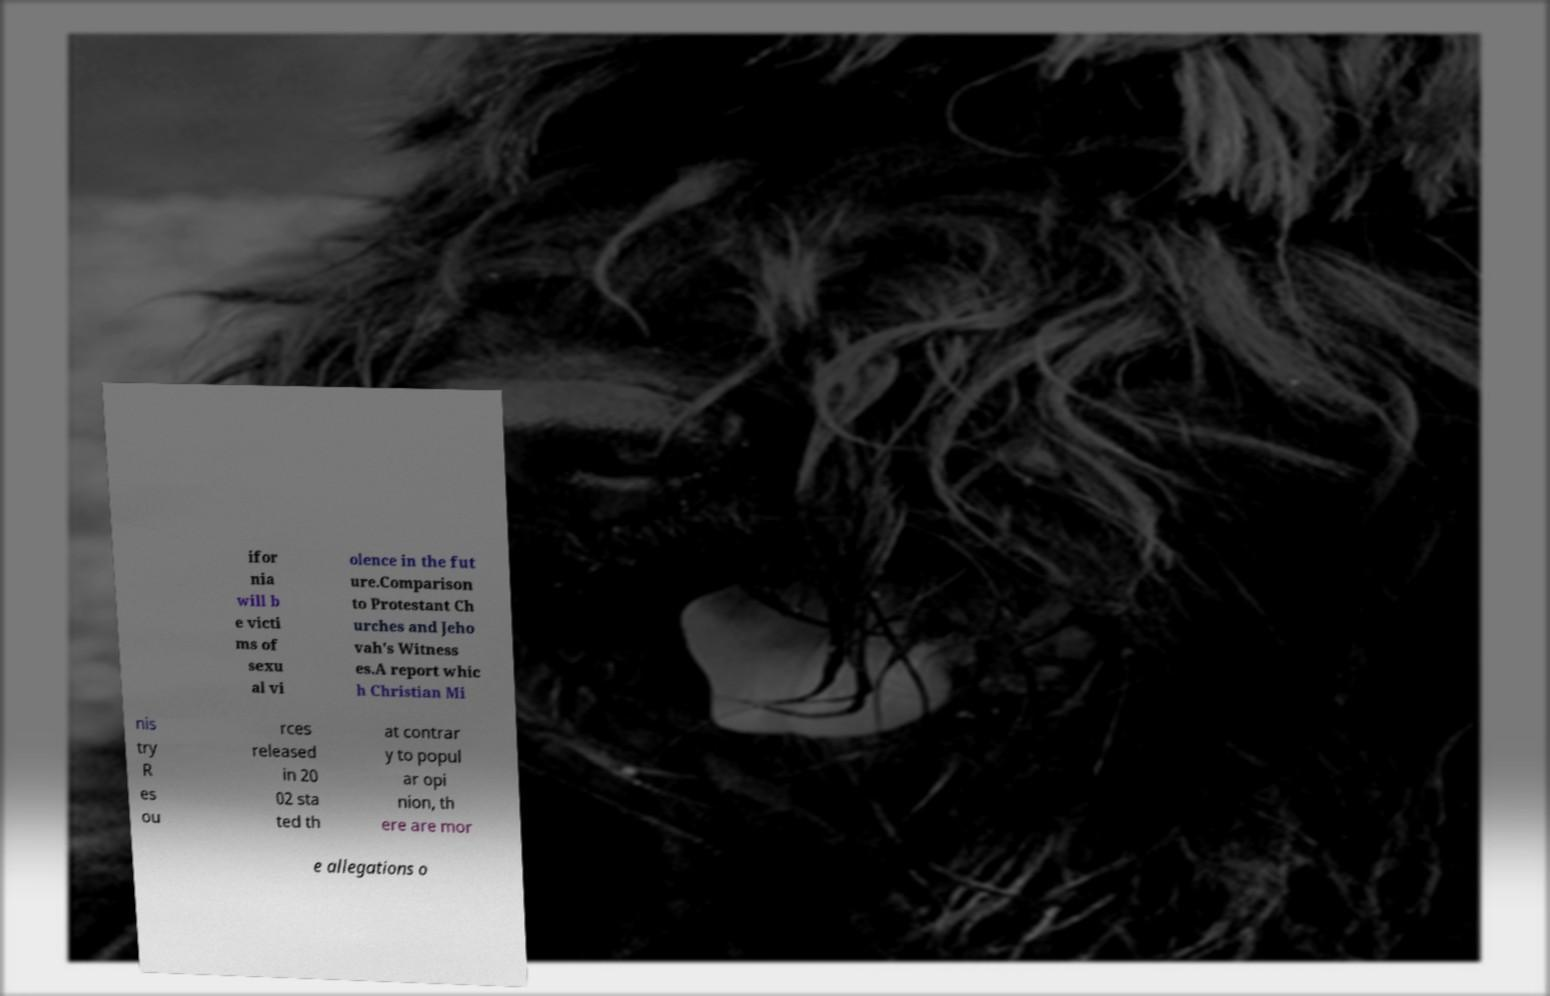Please read and relay the text visible in this image. What does it say? ifor nia will b e victi ms of sexu al vi olence in the fut ure.Comparison to Protestant Ch urches and Jeho vah's Witness es.A report whic h Christian Mi nis try R es ou rces released in 20 02 sta ted th at contrar y to popul ar opi nion, th ere are mor e allegations o 